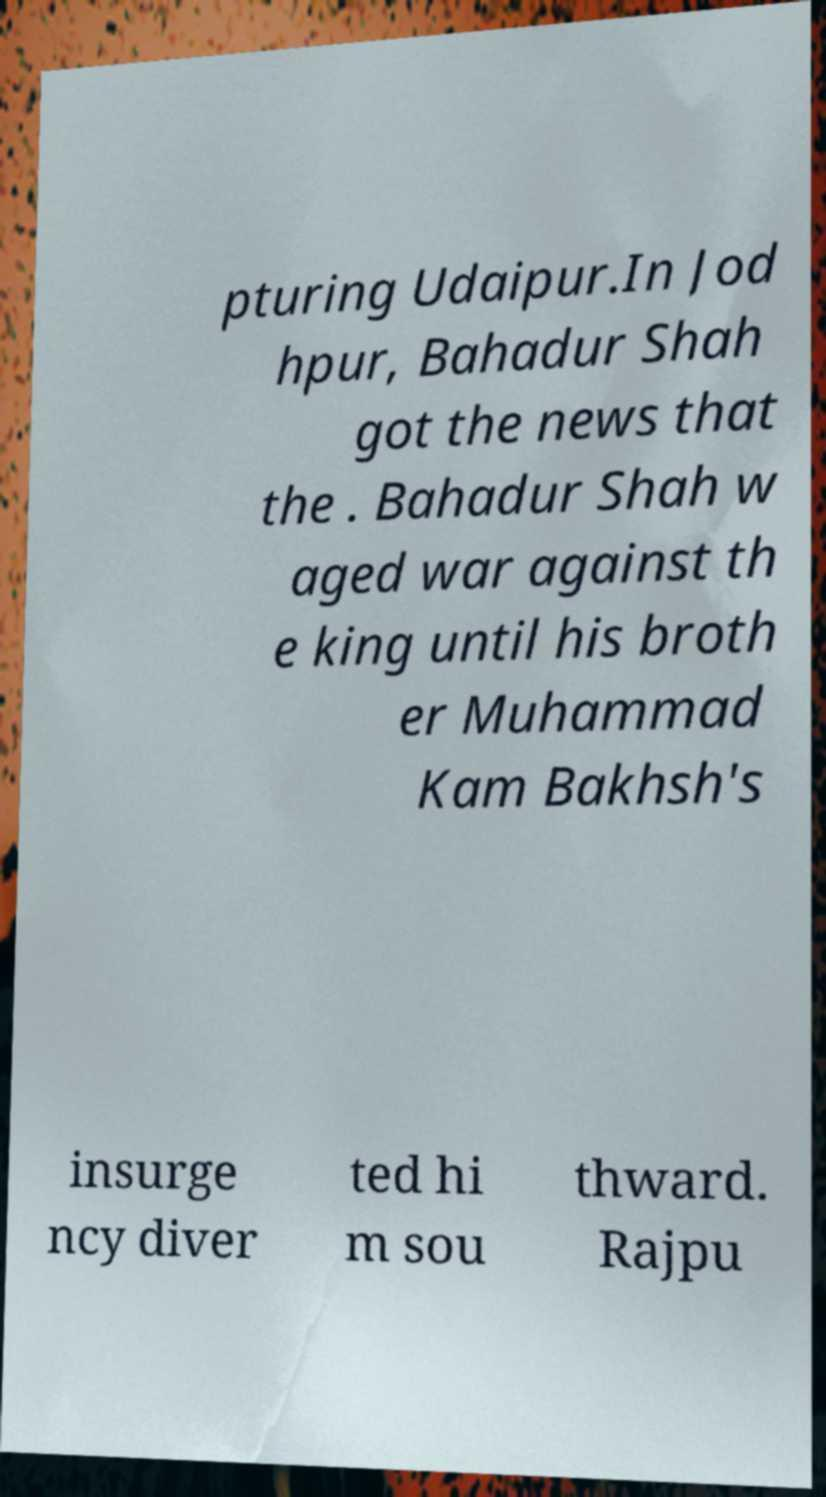Can you accurately transcribe the text from the provided image for me? pturing Udaipur.In Jod hpur, Bahadur Shah got the news that the . Bahadur Shah w aged war against th e king until his broth er Muhammad Kam Bakhsh's insurge ncy diver ted hi m sou thward. Rajpu 